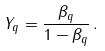Convert formula to latex. <formula><loc_0><loc_0><loc_500><loc_500>Y _ { q } = \frac { \beta _ { q } } { 1 - \beta _ { q } } \, .</formula> 